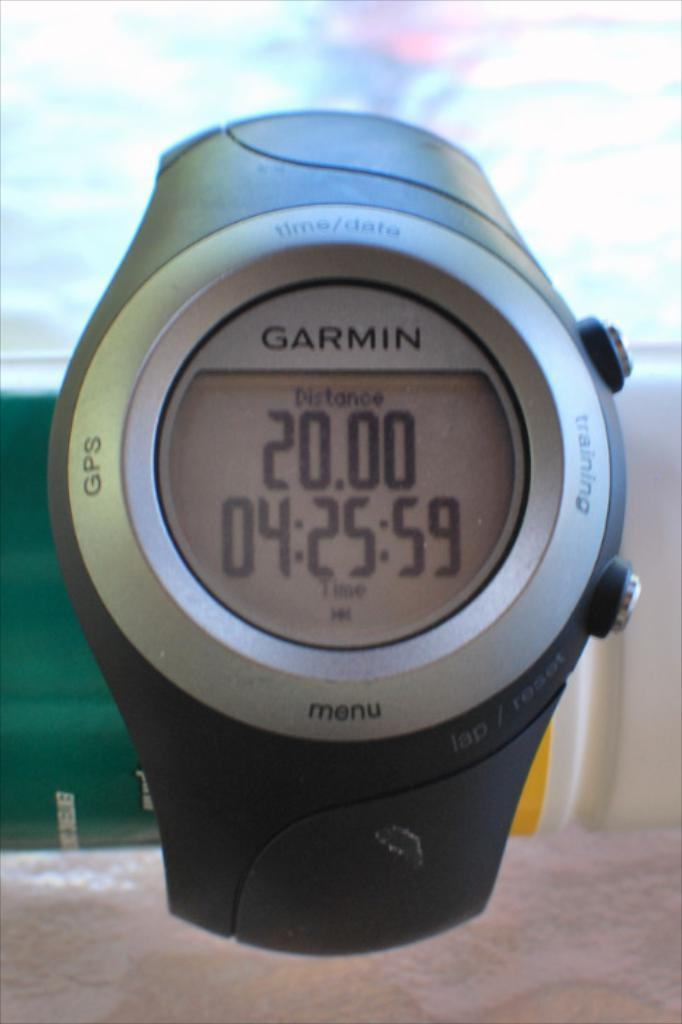Provide a one-sentence caption for the provided image. Distance of 20 is displayed on this Garmin smart watch. 